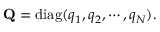Convert formula to latex. <formula><loc_0><loc_0><loc_500><loc_500>{ Q } = d i a g ( q _ { 1 } , q _ { 2 } , \cdots , q _ { N } ) .</formula> 